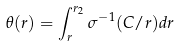Convert formula to latex. <formula><loc_0><loc_0><loc_500><loc_500>\theta ( r ) = \int _ { r } ^ { r _ { 2 } } \sigma ^ { - 1 } ( C / r ) d r</formula> 